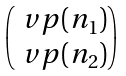Convert formula to latex. <formula><loc_0><loc_0><loc_500><loc_500>\begin{pmatrix} \ v p ( n _ { 1 } ) \\ \ v p ( n _ { 2 } ) \end{pmatrix}</formula> 